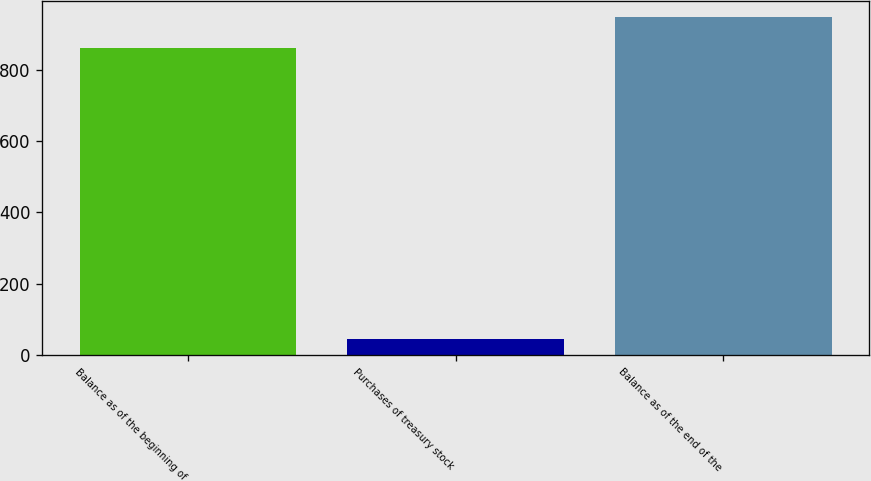<chart> <loc_0><loc_0><loc_500><loc_500><bar_chart><fcel>Balance as of the beginning of<fcel>Purchases of treasury stock<fcel>Balance as of the end of the<nl><fcel>860<fcel>45<fcel>946<nl></chart> 